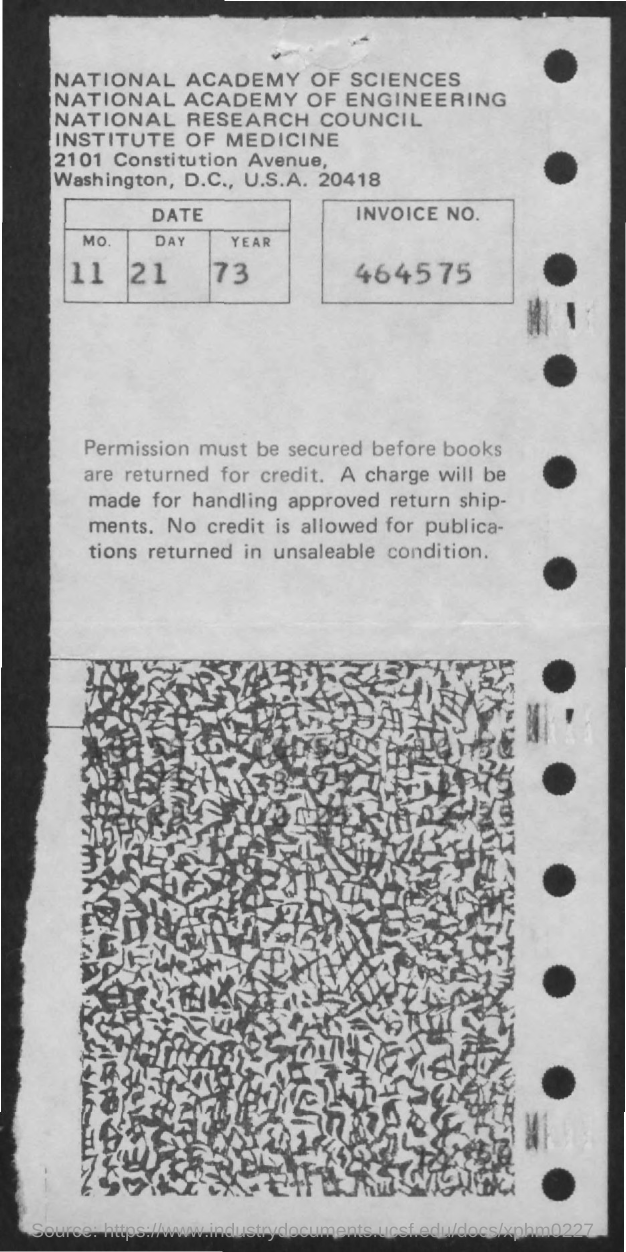What is the invoice no. given in the document?
Your response must be concise. 464575. What is the date mentioned in this document?
Provide a short and direct response. 11-21-73. 